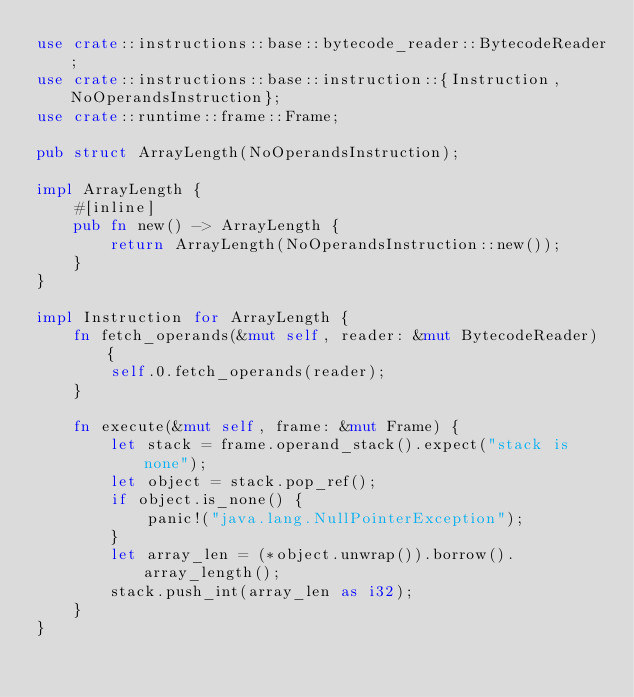Convert code to text. <code><loc_0><loc_0><loc_500><loc_500><_Rust_>use crate::instructions::base::bytecode_reader::BytecodeReader;
use crate::instructions::base::instruction::{Instruction, NoOperandsInstruction};
use crate::runtime::frame::Frame;

pub struct ArrayLength(NoOperandsInstruction);

impl ArrayLength {
    #[inline]
    pub fn new() -> ArrayLength {
        return ArrayLength(NoOperandsInstruction::new());
    }
}

impl Instruction for ArrayLength {
    fn fetch_operands(&mut self, reader: &mut BytecodeReader) {
        self.0.fetch_operands(reader);
    }

    fn execute(&mut self, frame: &mut Frame) {
        let stack = frame.operand_stack().expect("stack is none");
        let object = stack.pop_ref();
        if object.is_none() {
            panic!("java.lang.NullPointerException");
        }
        let array_len = (*object.unwrap()).borrow().array_length();
        stack.push_int(array_len as i32);
    }
}
</code> 